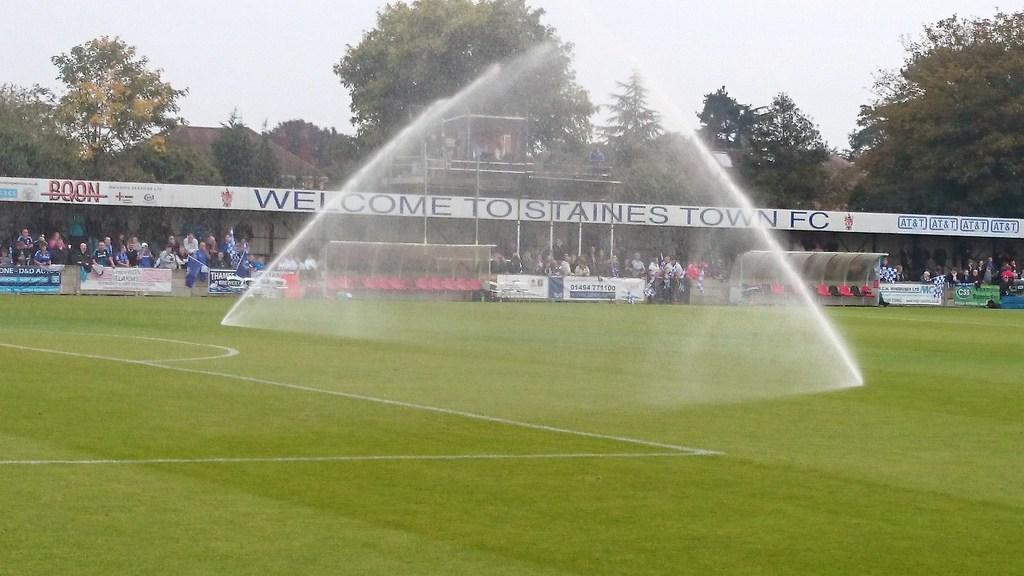<image>
Give a short and clear explanation of the subsequent image. the word welcome is on the white sign 